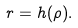<formula> <loc_0><loc_0><loc_500><loc_500>r = h ( \rho ) .</formula> 